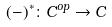<formula> <loc_0><loc_0><loc_500><loc_500>( - ) ^ { * } \colon C ^ { o p } \rightarrow C</formula> 